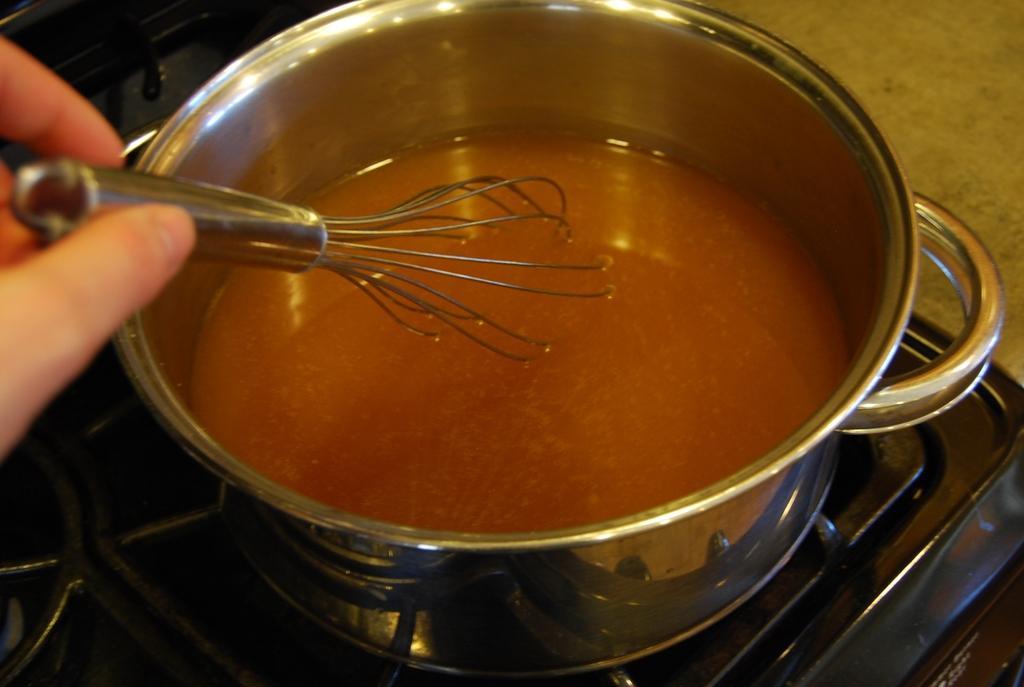Could you give a brief overview of what you see in this image? In this image, we can see a cooking pot with some liquid is placed on the black stove. Here we can see a human fingers with steel whisker. Right side top corner, there is surface. 